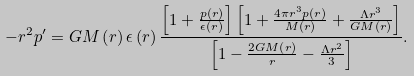Convert formula to latex. <formula><loc_0><loc_0><loc_500><loc_500>- r ^ { 2 } p ^ { \prime } = G M \left ( r \right ) \epsilon \left ( r \right ) \frac { \left [ 1 + \frac { p \left ( r \right ) } { \epsilon \left ( r \right ) } \right ] \left [ 1 + \frac { 4 \pi r ^ { 3 } p \left ( r \right ) } { M \left ( r \right ) } + \frac { \Lambda r ^ { 3 } } { G M \left ( r \right ) } \right ] } { \left [ 1 - \frac { 2 G M \left ( r \right ) } { r } - \frac { \Lambda r ^ { 2 } } { 3 } \right ] } .</formula> 